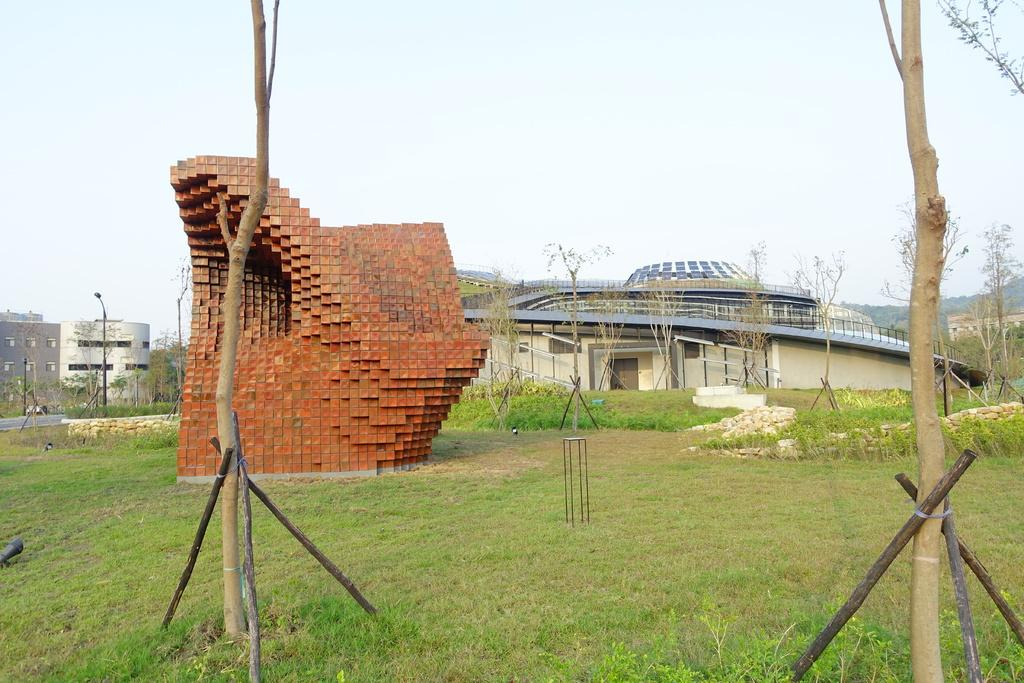What type of structures can be seen in the image? There are buildings in the image. What is covering the ground in the image? The ground is covered with greenery. What can be seen in the background of the image? There are trees in the background of the image. What is the average income of the people living in the buildings in the image? There is no information about the income of the people living in the buildings in the image. 